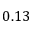<formula> <loc_0><loc_0><loc_500><loc_500>0 . 1 3</formula> 